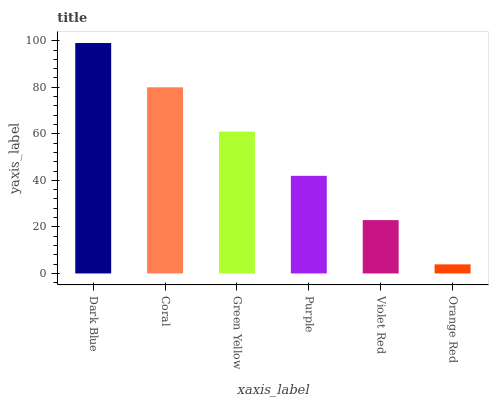Is Coral the minimum?
Answer yes or no. No. Is Coral the maximum?
Answer yes or no. No. Is Dark Blue greater than Coral?
Answer yes or no. Yes. Is Coral less than Dark Blue?
Answer yes or no. Yes. Is Coral greater than Dark Blue?
Answer yes or no. No. Is Dark Blue less than Coral?
Answer yes or no. No. Is Green Yellow the high median?
Answer yes or no. Yes. Is Purple the low median?
Answer yes or no. Yes. Is Dark Blue the high median?
Answer yes or no. No. Is Dark Blue the low median?
Answer yes or no. No. 